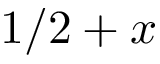Convert formula to latex. <formula><loc_0><loc_0><loc_500><loc_500>1 / 2 + x</formula> 